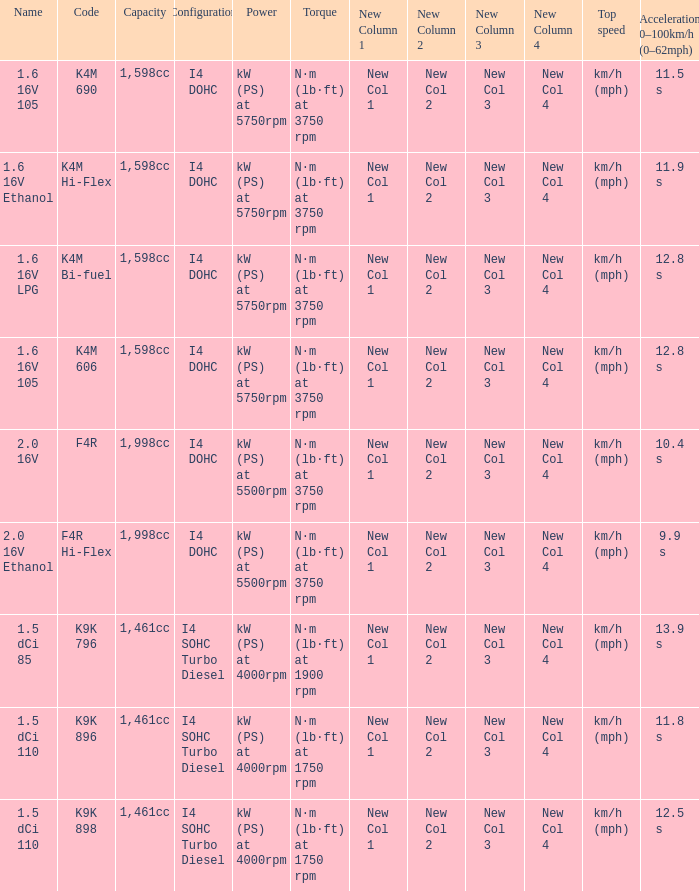What is the capacity of code f4r? 1,998cc. 